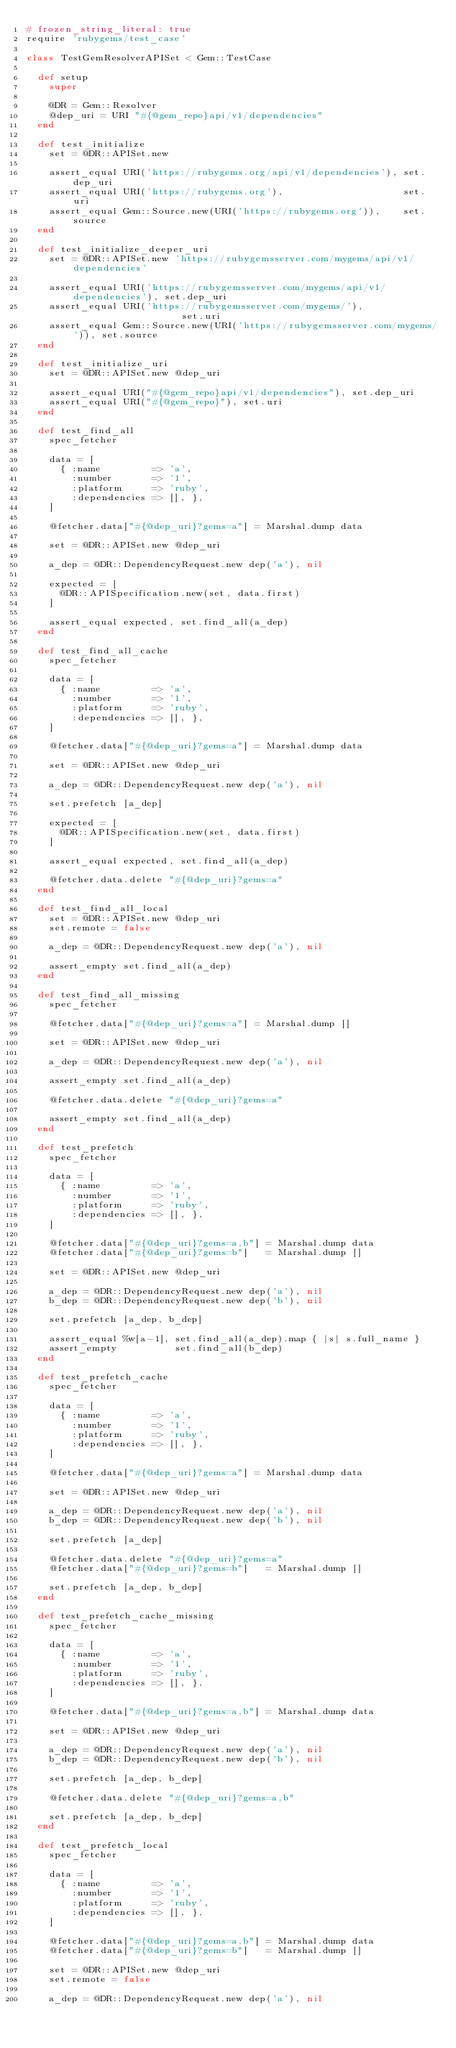Convert code to text. <code><loc_0><loc_0><loc_500><loc_500><_Ruby_># frozen_string_literal: true
require 'rubygems/test_case'

class TestGemResolverAPISet < Gem::TestCase

  def setup
    super

    @DR = Gem::Resolver
    @dep_uri = URI "#{@gem_repo}api/v1/dependencies"
  end

  def test_initialize
    set = @DR::APISet.new

    assert_equal URI('https://rubygems.org/api/v1/dependencies'), set.dep_uri
    assert_equal URI('https://rubygems.org'),                     set.uri
    assert_equal Gem::Source.new(URI('https://rubygems.org')),    set.source
  end

  def test_initialize_deeper_uri
    set = @DR::APISet.new 'https://rubygemsserver.com/mygems/api/v1/dependencies'

    assert_equal URI('https://rubygemsserver.com/mygems/api/v1/dependencies'), set.dep_uri
    assert_equal URI('https://rubygemsserver.com/mygems/'),                    set.uri
    assert_equal Gem::Source.new(URI('https://rubygemsserver.com/mygems/')), set.source
  end

  def test_initialize_uri
    set = @DR::APISet.new @dep_uri

    assert_equal URI("#{@gem_repo}api/v1/dependencies"), set.dep_uri
    assert_equal URI("#{@gem_repo}"), set.uri
  end

  def test_find_all
    spec_fetcher

    data = [
      { :name         => 'a',
        :number       => '1',
        :platform     => 'ruby',
        :dependencies => [], },
    ]

    @fetcher.data["#{@dep_uri}?gems=a"] = Marshal.dump data

    set = @DR::APISet.new @dep_uri

    a_dep = @DR::DependencyRequest.new dep('a'), nil

    expected = [
      @DR::APISpecification.new(set, data.first)
    ]

    assert_equal expected, set.find_all(a_dep)
  end

  def test_find_all_cache
    spec_fetcher

    data = [
      { :name         => 'a',
        :number       => '1',
        :platform     => 'ruby',
        :dependencies => [], },
    ]

    @fetcher.data["#{@dep_uri}?gems=a"] = Marshal.dump data

    set = @DR::APISet.new @dep_uri

    a_dep = @DR::DependencyRequest.new dep('a'), nil

    set.prefetch [a_dep]

    expected = [
      @DR::APISpecification.new(set, data.first)
    ]

    assert_equal expected, set.find_all(a_dep)

    @fetcher.data.delete "#{@dep_uri}?gems=a"
  end

  def test_find_all_local
    set = @DR::APISet.new @dep_uri
    set.remote = false

    a_dep = @DR::DependencyRequest.new dep('a'), nil

    assert_empty set.find_all(a_dep)
  end

  def test_find_all_missing
    spec_fetcher

    @fetcher.data["#{@dep_uri}?gems=a"] = Marshal.dump []

    set = @DR::APISet.new @dep_uri

    a_dep = @DR::DependencyRequest.new dep('a'), nil

    assert_empty set.find_all(a_dep)

    @fetcher.data.delete "#{@dep_uri}?gems=a"

    assert_empty set.find_all(a_dep)
  end

  def test_prefetch
    spec_fetcher

    data = [
      { :name         => 'a',
        :number       => '1',
        :platform     => 'ruby',
        :dependencies => [], },
    ]

    @fetcher.data["#{@dep_uri}?gems=a,b"] = Marshal.dump data
    @fetcher.data["#{@dep_uri}?gems=b"]   = Marshal.dump []

    set = @DR::APISet.new @dep_uri

    a_dep = @DR::DependencyRequest.new dep('a'), nil
    b_dep = @DR::DependencyRequest.new dep('b'), nil

    set.prefetch [a_dep, b_dep]

    assert_equal %w[a-1], set.find_all(a_dep).map { |s| s.full_name }
    assert_empty          set.find_all(b_dep)
  end

  def test_prefetch_cache
    spec_fetcher

    data = [
      { :name         => 'a',
        :number       => '1',
        :platform     => 'ruby',
        :dependencies => [], },
    ]

    @fetcher.data["#{@dep_uri}?gems=a"] = Marshal.dump data

    set = @DR::APISet.new @dep_uri

    a_dep = @DR::DependencyRequest.new dep('a'), nil
    b_dep = @DR::DependencyRequest.new dep('b'), nil

    set.prefetch [a_dep]

    @fetcher.data.delete "#{@dep_uri}?gems=a"
    @fetcher.data["#{@dep_uri}?gems=b"]   = Marshal.dump []

    set.prefetch [a_dep, b_dep]
  end

  def test_prefetch_cache_missing
    spec_fetcher

    data = [
      { :name         => 'a',
        :number       => '1',
        :platform     => 'ruby',
        :dependencies => [], },
    ]

    @fetcher.data["#{@dep_uri}?gems=a,b"] = Marshal.dump data

    set = @DR::APISet.new @dep_uri

    a_dep = @DR::DependencyRequest.new dep('a'), nil
    b_dep = @DR::DependencyRequest.new dep('b'), nil

    set.prefetch [a_dep, b_dep]

    @fetcher.data.delete "#{@dep_uri}?gems=a,b"

    set.prefetch [a_dep, b_dep]
  end

  def test_prefetch_local
    spec_fetcher

    data = [
      { :name         => 'a',
        :number       => '1',
        :platform     => 'ruby',
        :dependencies => [], },
    ]

    @fetcher.data["#{@dep_uri}?gems=a,b"] = Marshal.dump data
    @fetcher.data["#{@dep_uri}?gems=b"]   = Marshal.dump []

    set = @DR::APISet.new @dep_uri
    set.remote = false

    a_dep = @DR::DependencyRequest.new dep('a'), nil</code> 